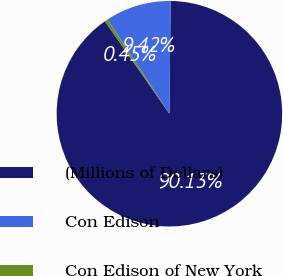Convert chart to OTSL. <chart><loc_0><loc_0><loc_500><loc_500><pie_chart><fcel>(Millions of Dollars)<fcel>Con Edison<fcel>Con Edison of New York<nl><fcel>90.13%<fcel>9.42%<fcel>0.45%<nl></chart> 